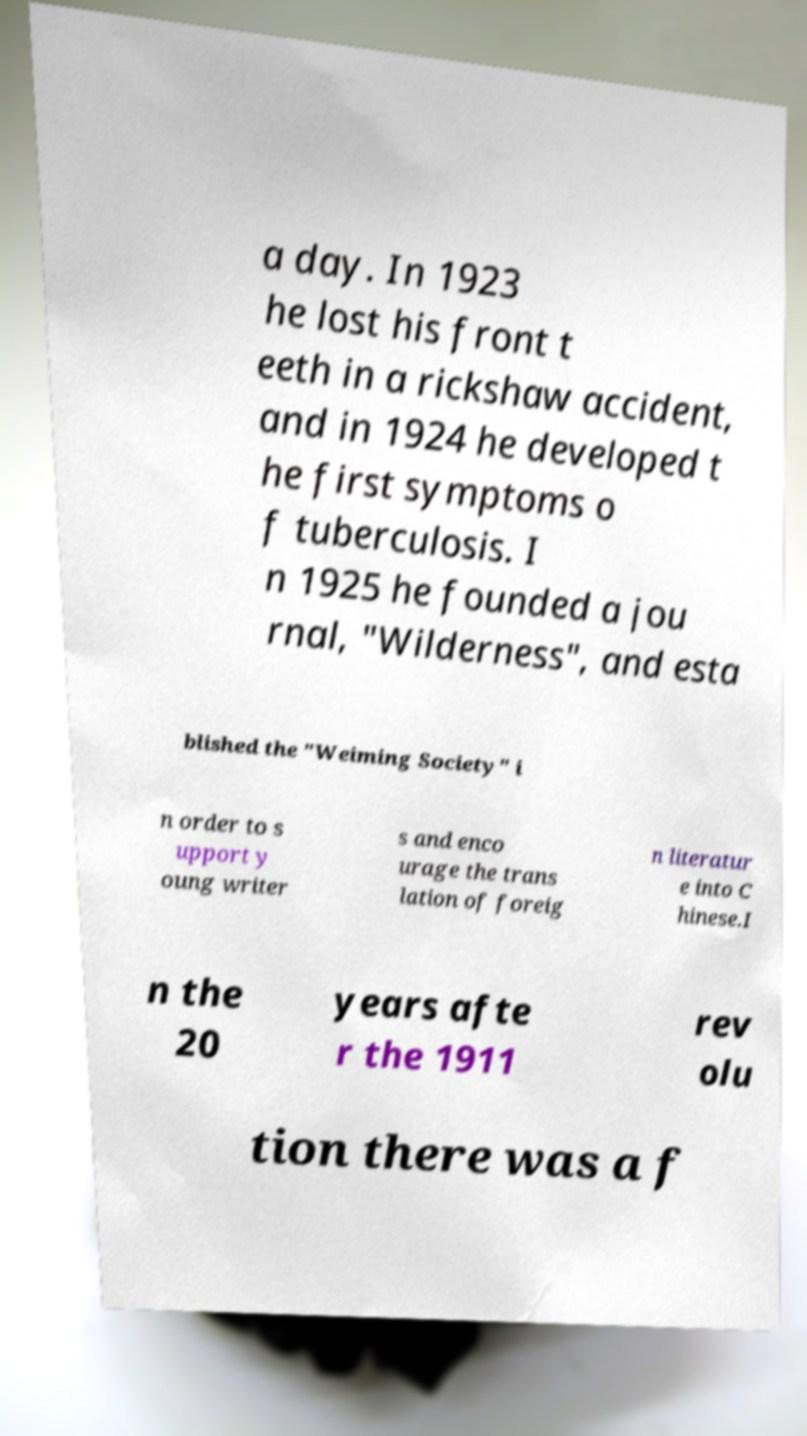Can you accurately transcribe the text from the provided image for me? a day. In 1923 he lost his front t eeth in a rickshaw accident, and in 1924 he developed t he first symptoms o f tuberculosis. I n 1925 he founded a jou rnal, "Wilderness", and esta blished the "Weiming Society" i n order to s upport y oung writer s and enco urage the trans lation of foreig n literatur e into C hinese.I n the 20 years afte r the 1911 rev olu tion there was a f 